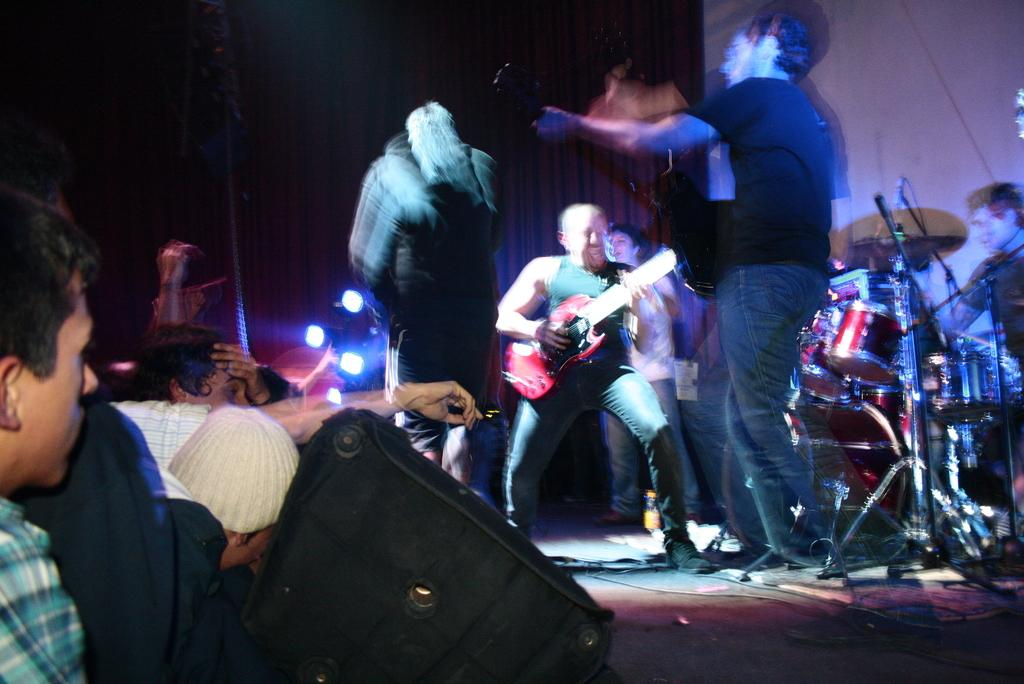What are the people on the stage doing? The people on the stage are playing musical instruments. What can be seen in front of the stage? There are people in front of the stage. What can be observed in the image related to lighting? There are lights visible in the image. What is present to amplify the sound of the musical instruments? There is a speaker present. How many hands are visible in the image? The number of hands visible in the image cannot be determined from the provided facts. What is the acoustics of the room like in the image? The acoustics of the room cannot be determined from the provided facts. 